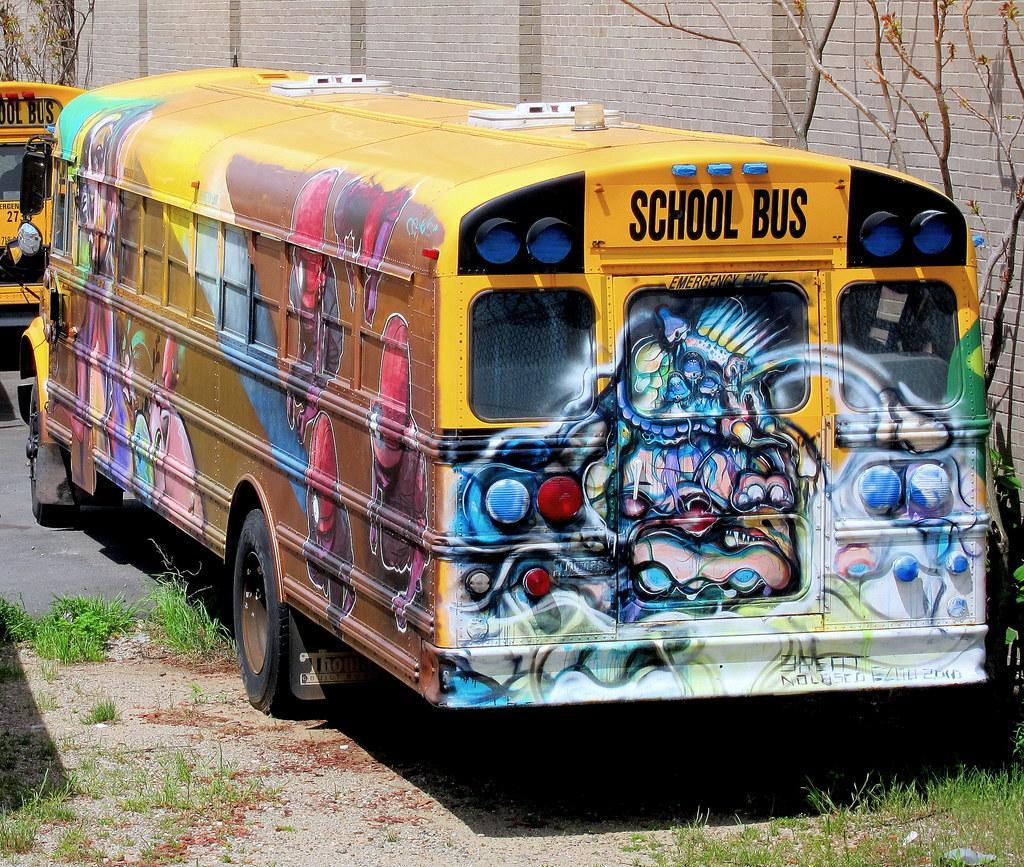In one or two sentences, can you explain what this image depicts? In this image we can see two buses on the ground. We can also see some grass, plants, the branches of a tree and a wall. 